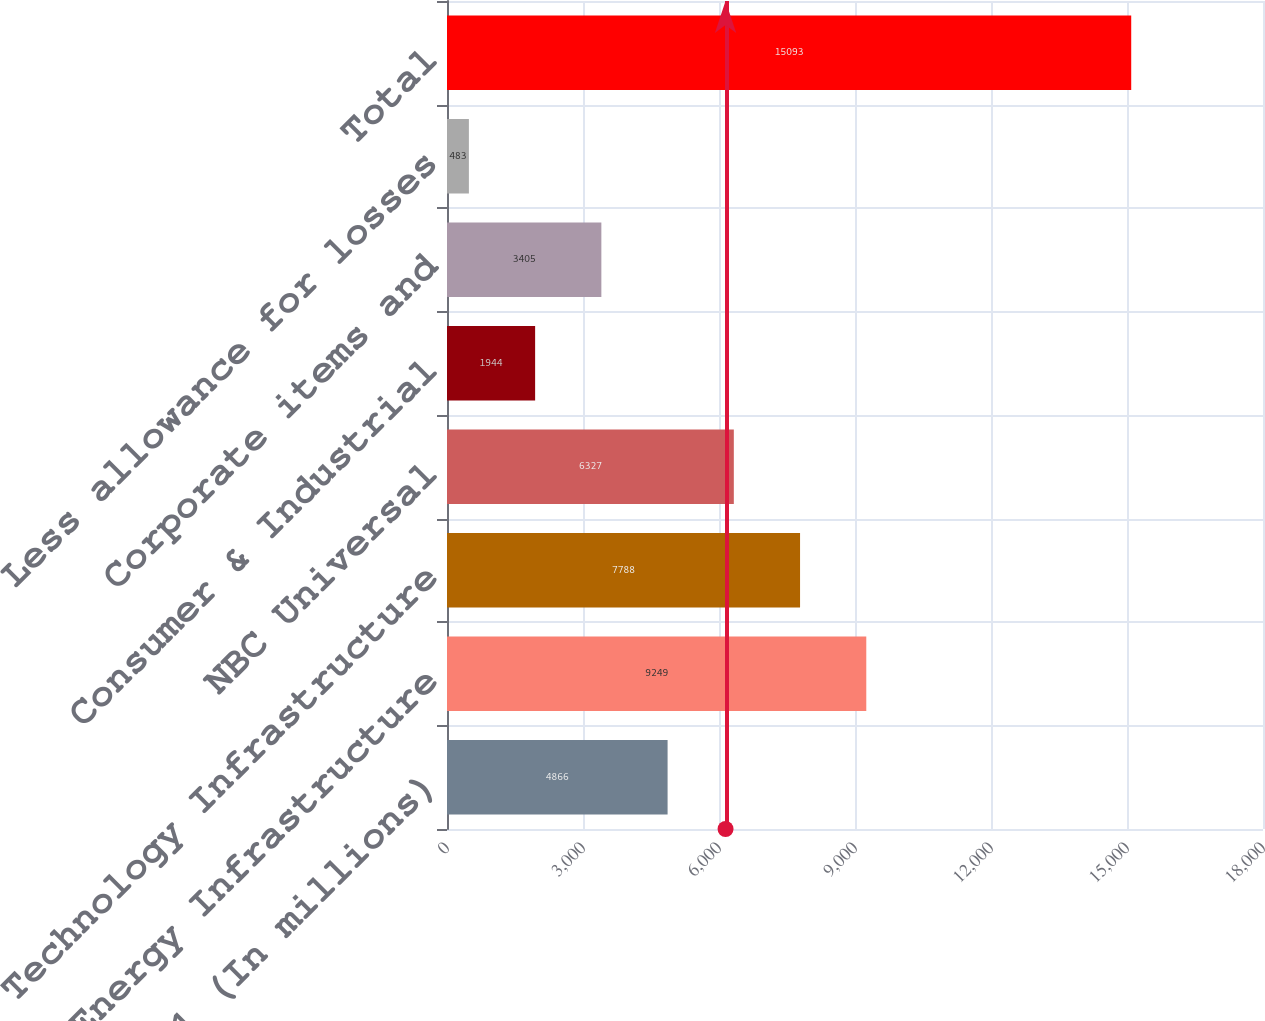Convert chart to OTSL. <chart><loc_0><loc_0><loc_500><loc_500><bar_chart><fcel>December 31 (In millions)<fcel>Energy Infrastructure<fcel>Technology Infrastructure<fcel>NBC Universal<fcel>Consumer & Industrial<fcel>Corporate items and<fcel>Less allowance for losses<fcel>Total<nl><fcel>4866<fcel>9249<fcel>7788<fcel>6327<fcel>1944<fcel>3405<fcel>483<fcel>15093<nl></chart> 